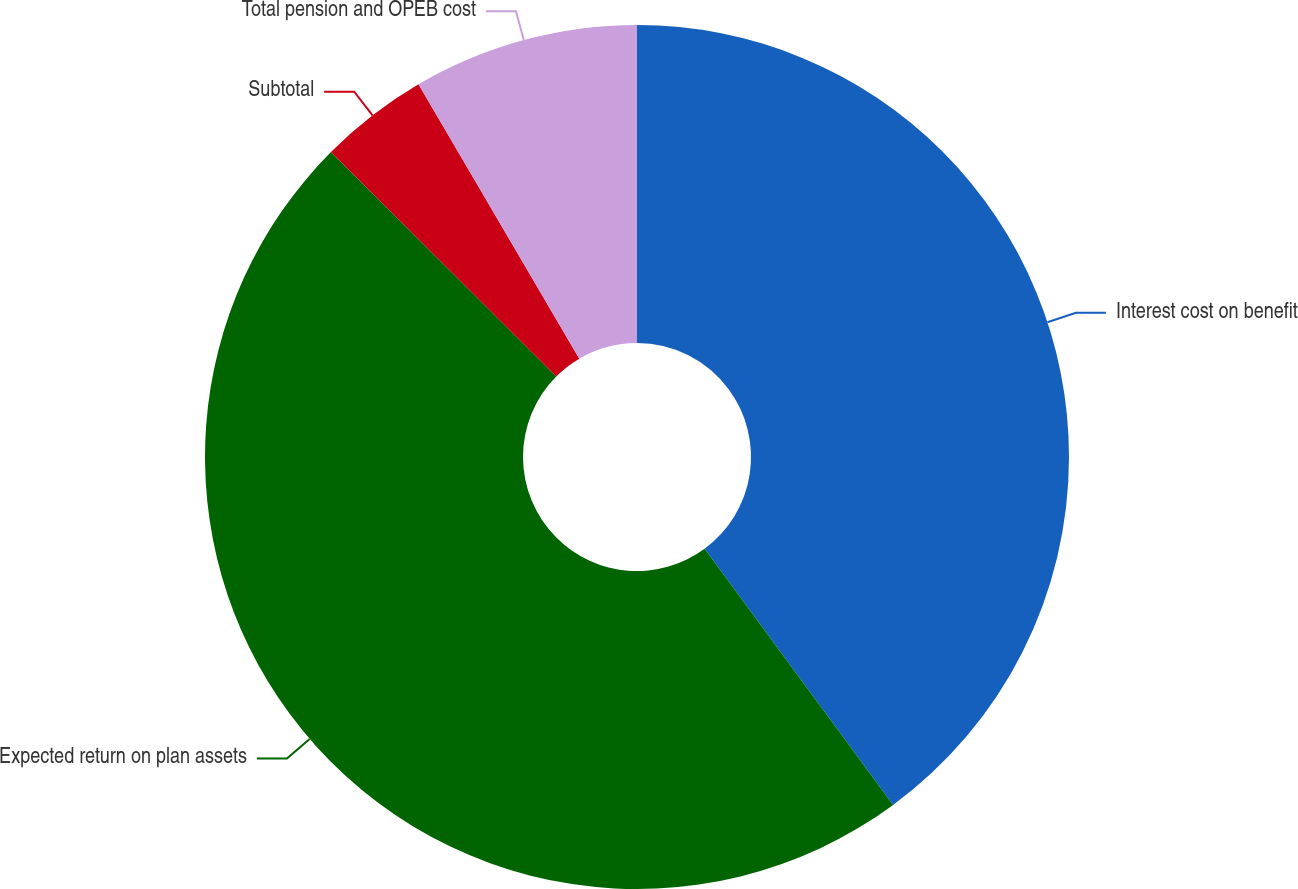Convert chart. <chart><loc_0><loc_0><loc_500><loc_500><pie_chart><fcel>Interest cost on benefit<fcel>Expected return on plan assets<fcel>Subtotal<fcel>Total pension and OPEB cost<nl><fcel>39.9%<fcel>47.57%<fcel>4.09%<fcel>8.44%<nl></chart> 